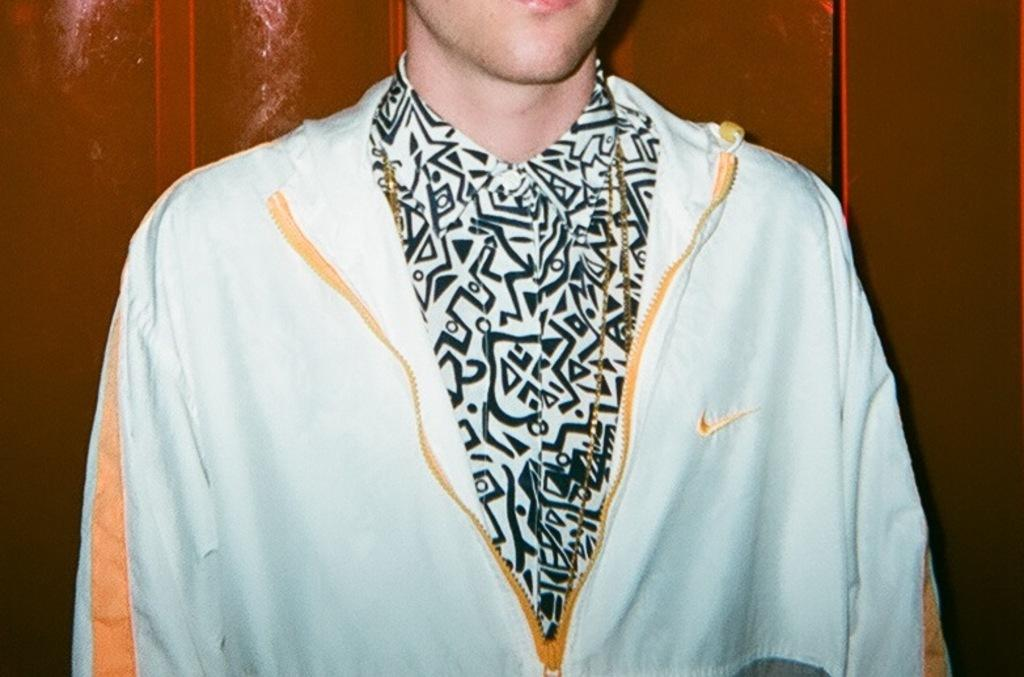Who is the main subject in the image? There is a man in the center of the image. What is the man wearing in the image? The man is wearing a jacket and a chain. What position does the man hold in the image? The facts provided do not mention any specific position or role for the man in the image. 